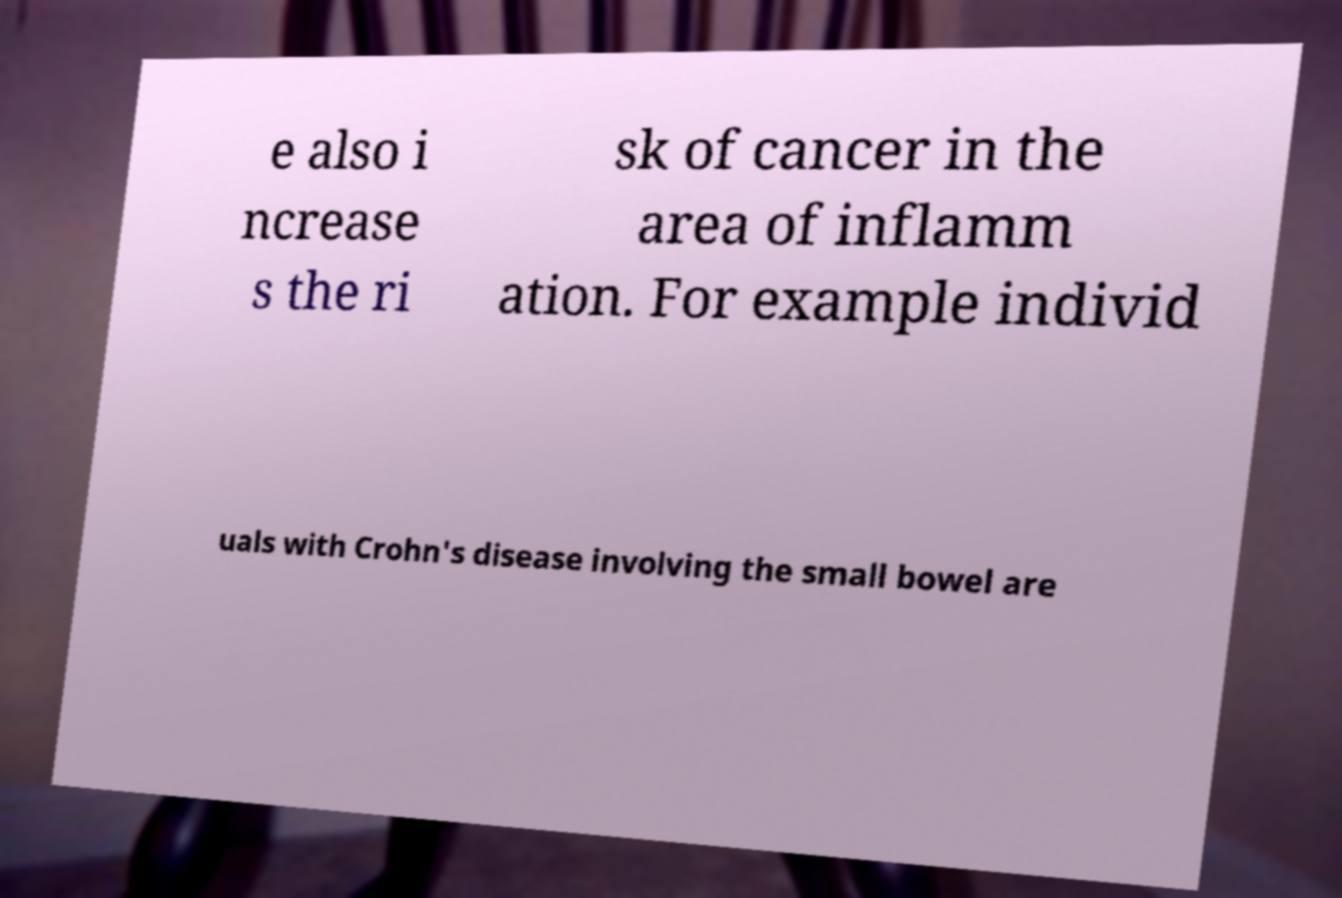Can you accurately transcribe the text from the provided image for me? e also i ncrease s the ri sk of cancer in the area of inflamm ation. For example individ uals with Crohn's disease involving the small bowel are 